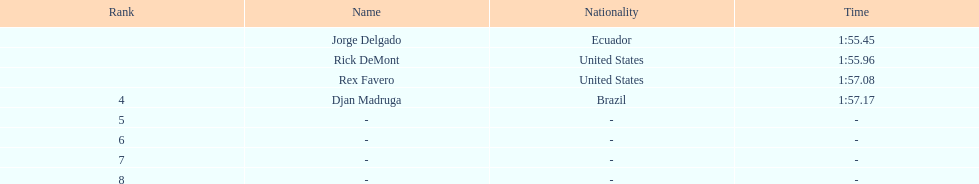Would you mind parsing the complete table? {'header': ['Rank', 'Name', 'Nationality', 'Time'], 'rows': [['', 'Jorge Delgado', 'Ecuador', '1:55.45'], ['', 'Rick DeMont', 'United States', '1:55.96'], ['', 'Rex Favero', 'United States', '1:57.08'], ['4', 'Djan Madruga', 'Brazil', '1:57.17'], ['5', '-', '-', '-'], ['6', '-', '-', '-'], ['7', '-', '-', '-'], ['8', '-', '-', '-']]} Can you provide the time allocated for every name? 1:55.45, 1:55.96, 1:57.08, 1:57.17. 